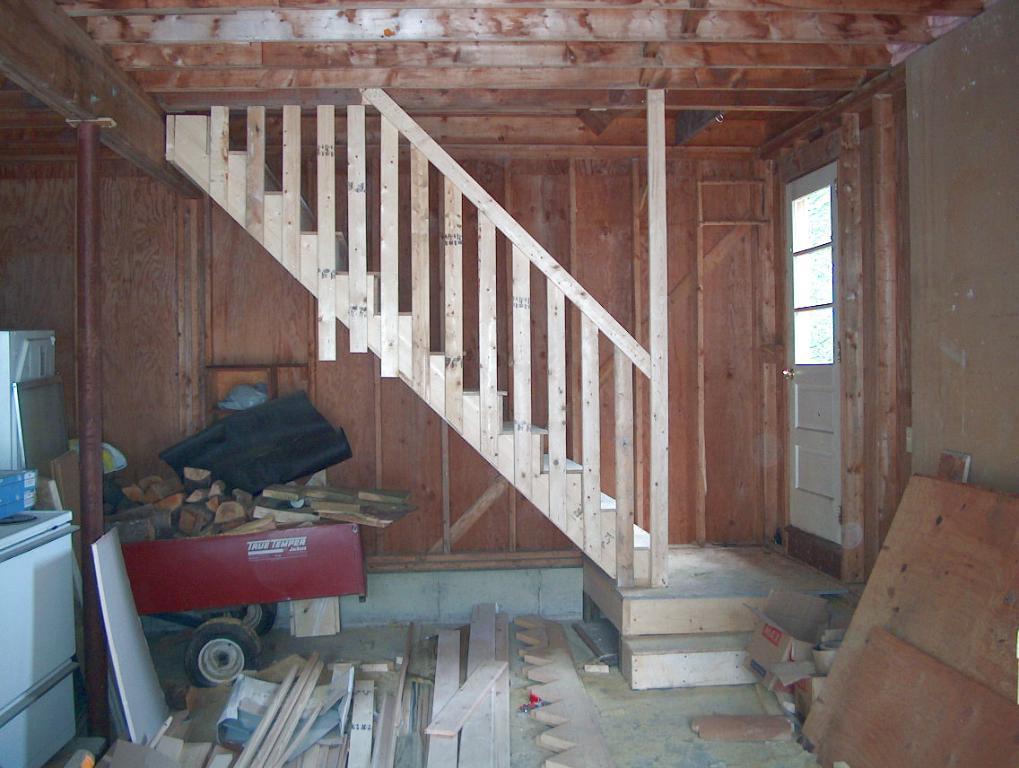Please provide a concise description of this image. In this image I can see there are wooden stairs and there is a door at right. There are few wooden pieces placed on a trolley and there are few wooden planks and they are cut into a design. 